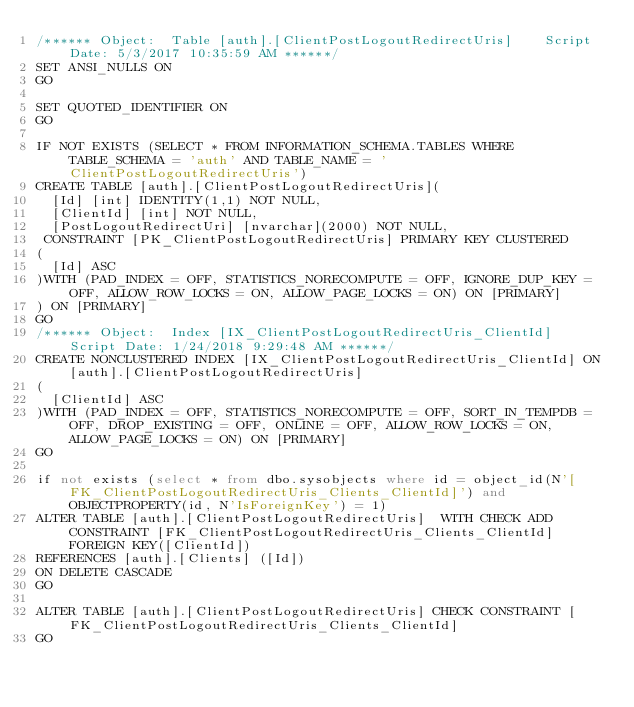Convert code to text. <code><loc_0><loc_0><loc_500><loc_500><_SQL_>/****** Object:  Table [auth].[ClientPostLogoutRedirectUris]    Script Date: 5/3/2017 10:35:59 AM ******/
SET ANSI_NULLS ON
GO

SET QUOTED_IDENTIFIER ON
GO

IF NOT EXISTS (SELECT * FROM INFORMATION_SCHEMA.TABLES WHERE TABLE_SCHEMA = 'auth' AND TABLE_NAME = 'ClientPostLogoutRedirectUris')
CREATE TABLE [auth].[ClientPostLogoutRedirectUris](
	[Id] [int] IDENTITY(1,1) NOT NULL,
	[ClientId] [int] NOT NULL,
	[PostLogoutRedirectUri] [nvarchar](2000) NOT NULL,
 CONSTRAINT [PK_ClientPostLogoutRedirectUris] PRIMARY KEY CLUSTERED 
(
	[Id] ASC
)WITH (PAD_INDEX = OFF, STATISTICS_NORECOMPUTE = OFF, IGNORE_DUP_KEY = OFF, ALLOW_ROW_LOCKS = ON, ALLOW_PAGE_LOCKS = ON) ON [PRIMARY]
) ON [PRIMARY]
GO
/****** Object:  Index [IX_ClientPostLogoutRedirectUris_ClientId]    Script Date: 1/24/2018 9:29:48 AM ******/
CREATE NONCLUSTERED INDEX [IX_ClientPostLogoutRedirectUris_ClientId] ON [auth].[ClientPostLogoutRedirectUris]
(
	[ClientId] ASC
)WITH (PAD_INDEX = OFF, STATISTICS_NORECOMPUTE = OFF, SORT_IN_TEMPDB = OFF, DROP_EXISTING = OFF, ONLINE = OFF, ALLOW_ROW_LOCKS = ON, ALLOW_PAGE_LOCKS = ON) ON [PRIMARY]
GO

if not exists (select * from dbo.sysobjects where id = object_id(N'[FK_ClientPostLogoutRedirectUris_Clients_ClientId]') and OBJECTPROPERTY(id, N'IsForeignKey') = 1)
ALTER TABLE [auth].[ClientPostLogoutRedirectUris]  WITH CHECK ADD  CONSTRAINT [FK_ClientPostLogoutRedirectUris_Clients_ClientId] FOREIGN KEY([ClientId])
REFERENCES [auth].[Clients] ([Id])
ON DELETE CASCADE
GO

ALTER TABLE [auth].[ClientPostLogoutRedirectUris] CHECK CONSTRAINT [FK_ClientPostLogoutRedirectUris_Clients_ClientId]
GO</code> 